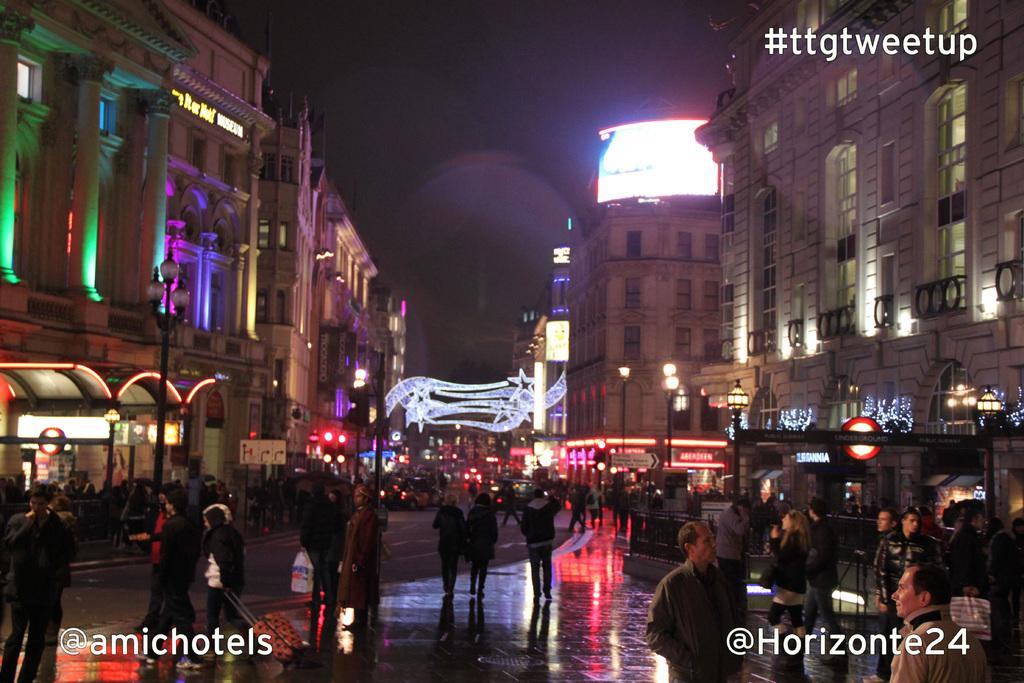How many people are in the group visible in the image? There is a group of people standing in the image, but the exact number cannot be determined from the provided facts. What type of structures can be seen in the image? There are buildings in the image. What are the poles used for in the image? The purpose of the poles in the image cannot be determined from the provided facts. What are the lights used for in the image? The purpose of the lights in the image cannot be determined from the provided facts. What are the boards used for in the image? The purpose of the boards in the image cannot be determined from the provided facts. Are there any visible watermarks in the image? Yes, the image has watermarks. What type of cake is being served at the event in the image? There is no event or cake present in the image; it features a group of people, buildings, poles, lights, and boards. 